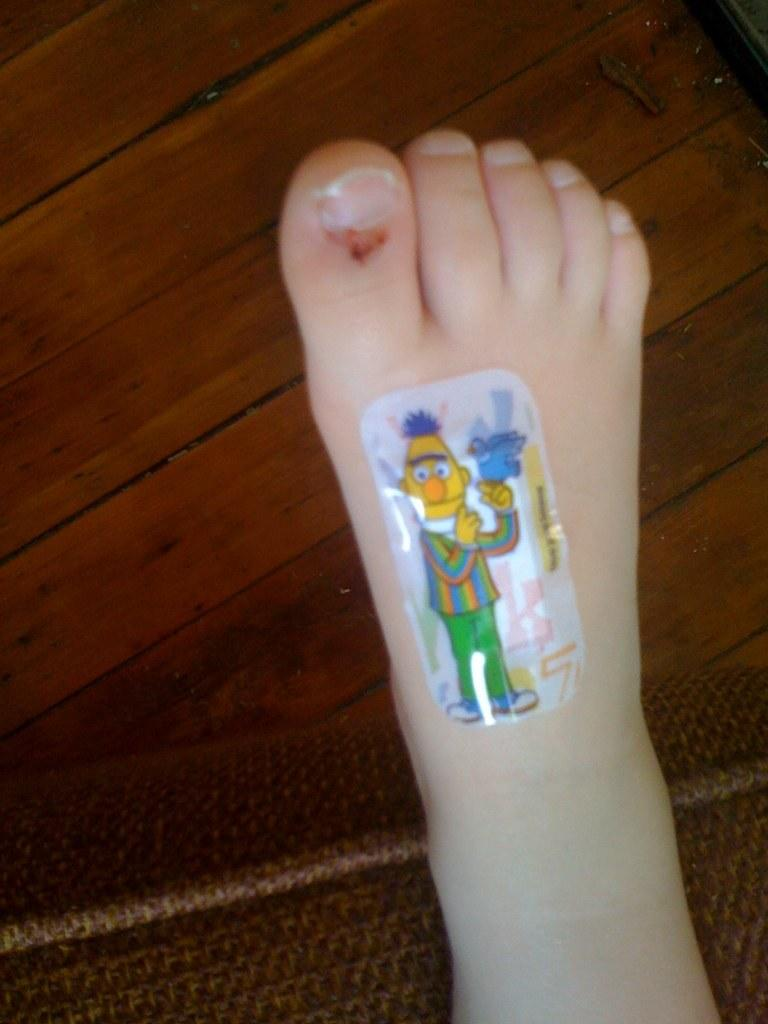What is on the person's leg in the image? There is a sticker on a person's leg in the image. What can be seen in the background of the image? There is a wooden platform and an object in the background of the image. What type of marble is being used to play a game on the wooden platform in the image? There is no marble or game visible in the image; it only features a sticker on a person's leg and a wooden platform in the background. 